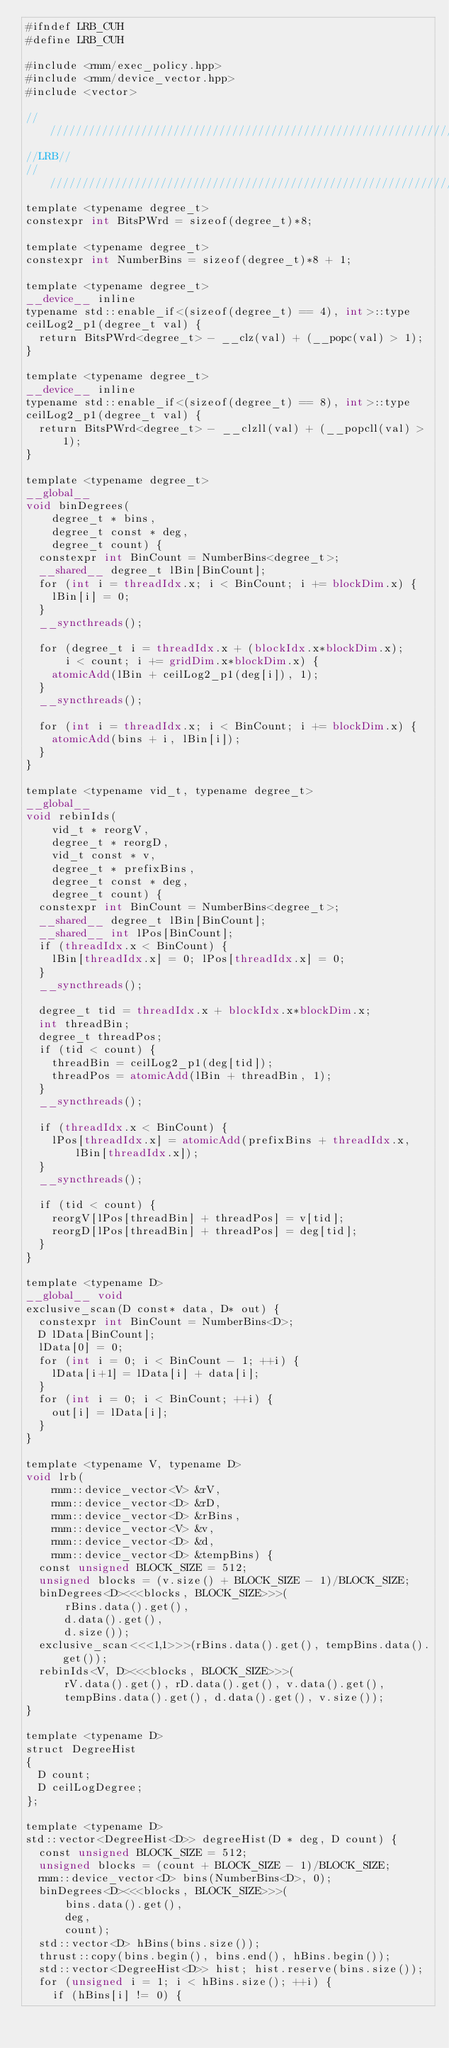Convert code to text. <code><loc_0><loc_0><loc_500><loc_500><_Cuda_>#ifndef LRB_CUH
#define LRB_CUH

#include <rmm/exec_policy.hpp>
#include <rmm/device_vector.hpp>
#include <vector>

////////////////////////////////////////////////////////////////
//LRB//
////////////////////////////////////////////////////////////////
template <typename degree_t>
constexpr int BitsPWrd = sizeof(degree_t)*8;

template <typename degree_t>
constexpr int NumberBins = sizeof(degree_t)*8 + 1;

template <typename degree_t>
__device__ inline
typename std::enable_if<(sizeof(degree_t) == 4), int>::type
ceilLog2_p1(degree_t val) {
  return BitsPWrd<degree_t> - __clz(val) + (__popc(val) > 1);
}

template <typename degree_t>
__device__ inline
typename std::enable_if<(sizeof(degree_t) == 8), int>::type
ceilLog2_p1(degree_t val) {
  return BitsPWrd<degree_t> - __clzll(val) + (__popcll(val) > 1);
}

template <typename degree_t>
__global__
void binDegrees(
    degree_t * bins,
    degree_t const * deg,
    degree_t count) {
  constexpr int BinCount = NumberBins<degree_t>;
  __shared__ degree_t lBin[BinCount];
  for (int i = threadIdx.x; i < BinCount; i += blockDim.x) {
    lBin[i] = 0;
  }
  __syncthreads();

  for (degree_t i = threadIdx.x + (blockIdx.x*blockDim.x);
      i < count; i += gridDim.x*blockDim.x) {
    atomicAdd(lBin + ceilLog2_p1(deg[i]), 1);
  }
  __syncthreads();

  for (int i = threadIdx.x; i < BinCount; i += blockDim.x) {
    atomicAdd(bins + i, lBin[i]);
  }
}

template <typename vid_t, typename degree_t>
__global__
void rebinIds(
    vid_t * reorgV,
    degree_t * reorgD,
    vid_t const * v,
    degree_t * prefixBins,
    degree_t const * deg,
    degree_t count) {
  constexpr int BinCount = NumberBins<degree_t>;
  __shared__ degree_t lBin[BinCount];
  __shared__ int lPos[BinCount];
  if (threadIdx.x < BinCount) {
    lBin[threadIdx.x] = 0; lPos[threadIdx.x] = 0;
  }
  __syncthreads();

  degree_t tid = threadIdx.x + blockIdx.x*blockDim.x;
  int threadBin;
  degree_t threadPos;
  if (tid < count) {
    threadBin = ceilLog2_p1(deg[tid]);
    threadPos = atomicAdd(lBin + threadBin, 1);
  }
  __syncthreads();

  if (threadIdx.x < BinCount) {
    lPos[threadIdx.x] = atomicAdd(prefixBins + threadIdx.x, lBin[threadIdx.x]);
  }
  __syncthreads();

  if (tid < count) {
    reorgV[lPos[threadBin] + threadPos] = v[tid];
    reorgD[lPos[threadBin] + threadPos] = deg[tid];
  }
}

template <typename D>
__global__ void
exclusive_scan(D const* data, D* out) {
  constexpr int BinCount = NumberBins<D>;
  D lData[BinCount];
  lData[0] = 0;
  for (int i = 0; i < BinCount - 1; ++i) {
    lData[i+1] = lData[i] + data[i];
  }
  for (int i = 0; i < BinCount; ++i) {
    out[i] = lData[i];
  }
}

template <typename V, typename D>
void lrb(
    rmm::device_vector<V> &rV,
    rmm::device_vector<D> &rD,
    rmm::device_vector<D> &rBins,
    rmm::device_vector<V> &v,
    rmm::device_vector<D> &d,
    rmm::device_vector<D> &tempBins) {
  const unsigned BLOCK_SIZE = 512;
  unsigned blocks = (v.size() + BLOCK_SIZE - 1)/BLOCK_SIZE;
  binDegrees<D><<<blocks, BLOCK_SIZE>>>(
      rBins.data().get(),
      d.data().get(),
      d.size());
  exclusive_scan<<<1,1>>>(rBins.data().get(), tempBins.data().get());
  rebinIds<V, D><<<blocks, BLOCK_SIZE>>>(
      rV.data().get(), rD.data().get(), v.data().get(),
      tempBins.data().get(), d.data().get(), v.size());
}

template <typename D>
struct DegreeHist
{
  D count;
  D ceilLogDegree;
};

template <typename D>
std::vector<DegreeHist<D>> degreeHist(D * deg, D count) {
  const unsigned BLOCK_SIZE = 512;
  unsigned blocks = (count + BLOCK_SIZE - 1)/BLOCK_SIZE;
  rmm::device_vector<D> bins(NumberBins<D>, 0);
  binDegrees<D><<<blocks, BLOCK_SIZE>>>(
      bins.data().get(),
      deg,
      count);
  std::vector<D> hBins(bins.size());
  thrust::copy(bins.begin(), bins.end(), hBins.begin());
  std::vector<DegreeHist<D>> hist; hist.reserve(bins.size());
  for (unsigned i = 1; i < hBins.size(); ++i) {
    if (hBins[i] != 0) {</code> 